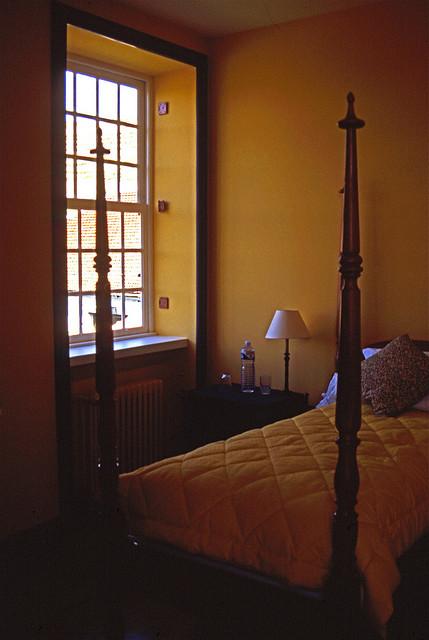What kind of drink is on the table?
Keep it brief. Water. What is on the corners of the bed?
Give a very brief answer. Posts. What would you do in this room?
Answer briefly. Sleep. 